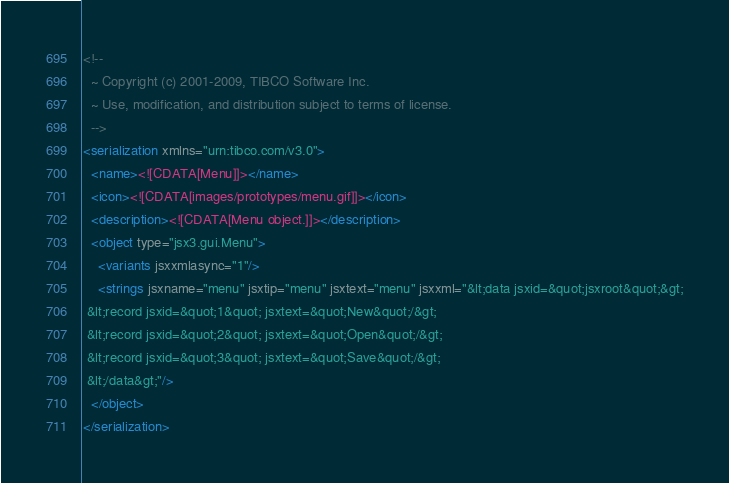<code> <loc_0><loc_0><loc_500><loc_500><_XML_><!--
  ~ Copyright (c) 2001-2009, TIBCO Software Inc.
  ~ Use, modification, and distribution subject to terms of license.
  -->
<serialization xmlns="urn:tibco.com/v3.0">
  <name><![CDATA[Menu]]></name>
  <icon><![CDATA[images/prototypes/menu.gif]]></icon>
  <description><![CDATA[Menu object.]]></description>
  <object type="jsx3.gui.Menu">
    <variants jsxxmlasync="1"/>
    <strings jsxname="menu" jsxtip="menu" jsxtext="menu" jsxxml="&lt;data jsxid=&quot;jsxroot&quot;&gt;
 &lt;record jsxid=&quot;1&quot; jsxtext=&quot;New&quot;/&gt;
 &lt;record jsxid=&quot;2&quot; jsxtext=&quot;Open&quot;/&gt;
 &lt;record jsxid=&quot;3&quot; jsxtext=&quot;Save&quot;/&gt;
 &lt;/data&gt;"/>
  </object>
</serialization></code> 